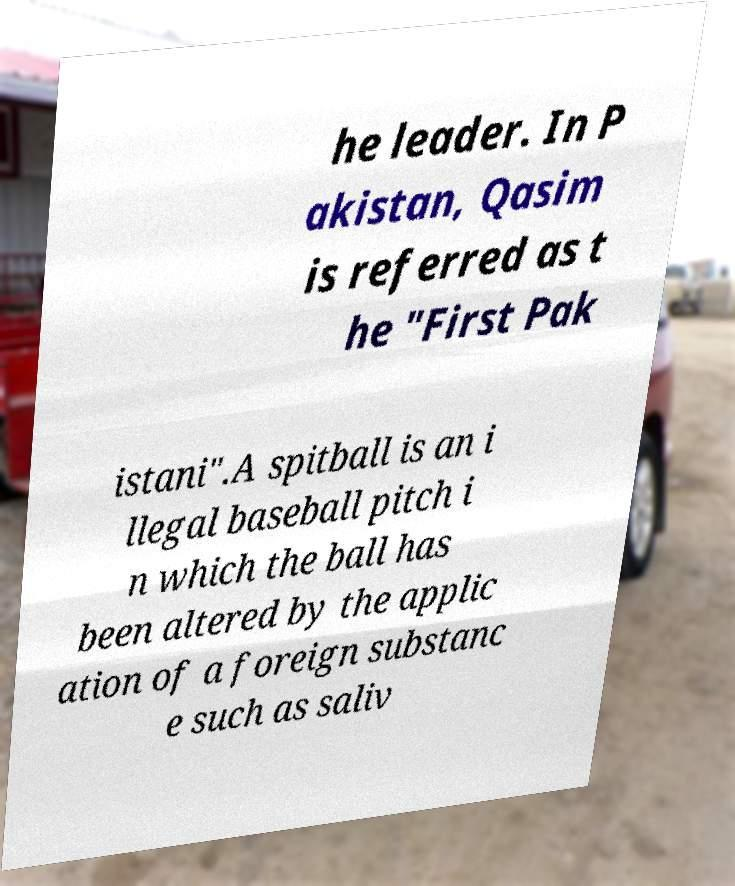Please identify and transcribe the text found in this image. he leader. In P akistan, Qasim is referred as t he "First Pak istani".A spitball is an i llegal baseball pitch i n which the ball has been altered by the applic ation of a foreign substanc e such as saliv 